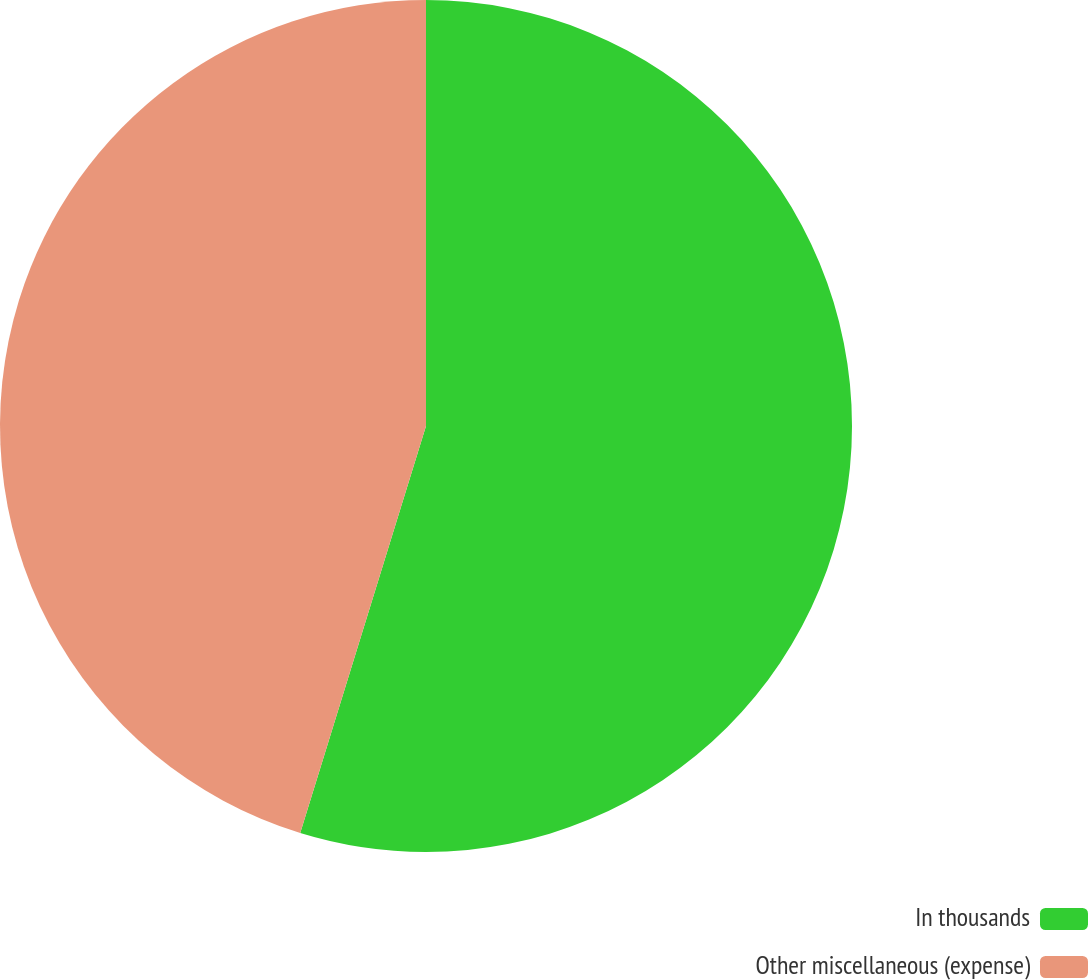<chart> <loc_0><loc_0><loc_500><loc_500><pie_chart><fcel>In thousands<fcel>Other miscellaneous (expense)<nl><fcel>54.77%<fcel>45.23%<nl></chart> 